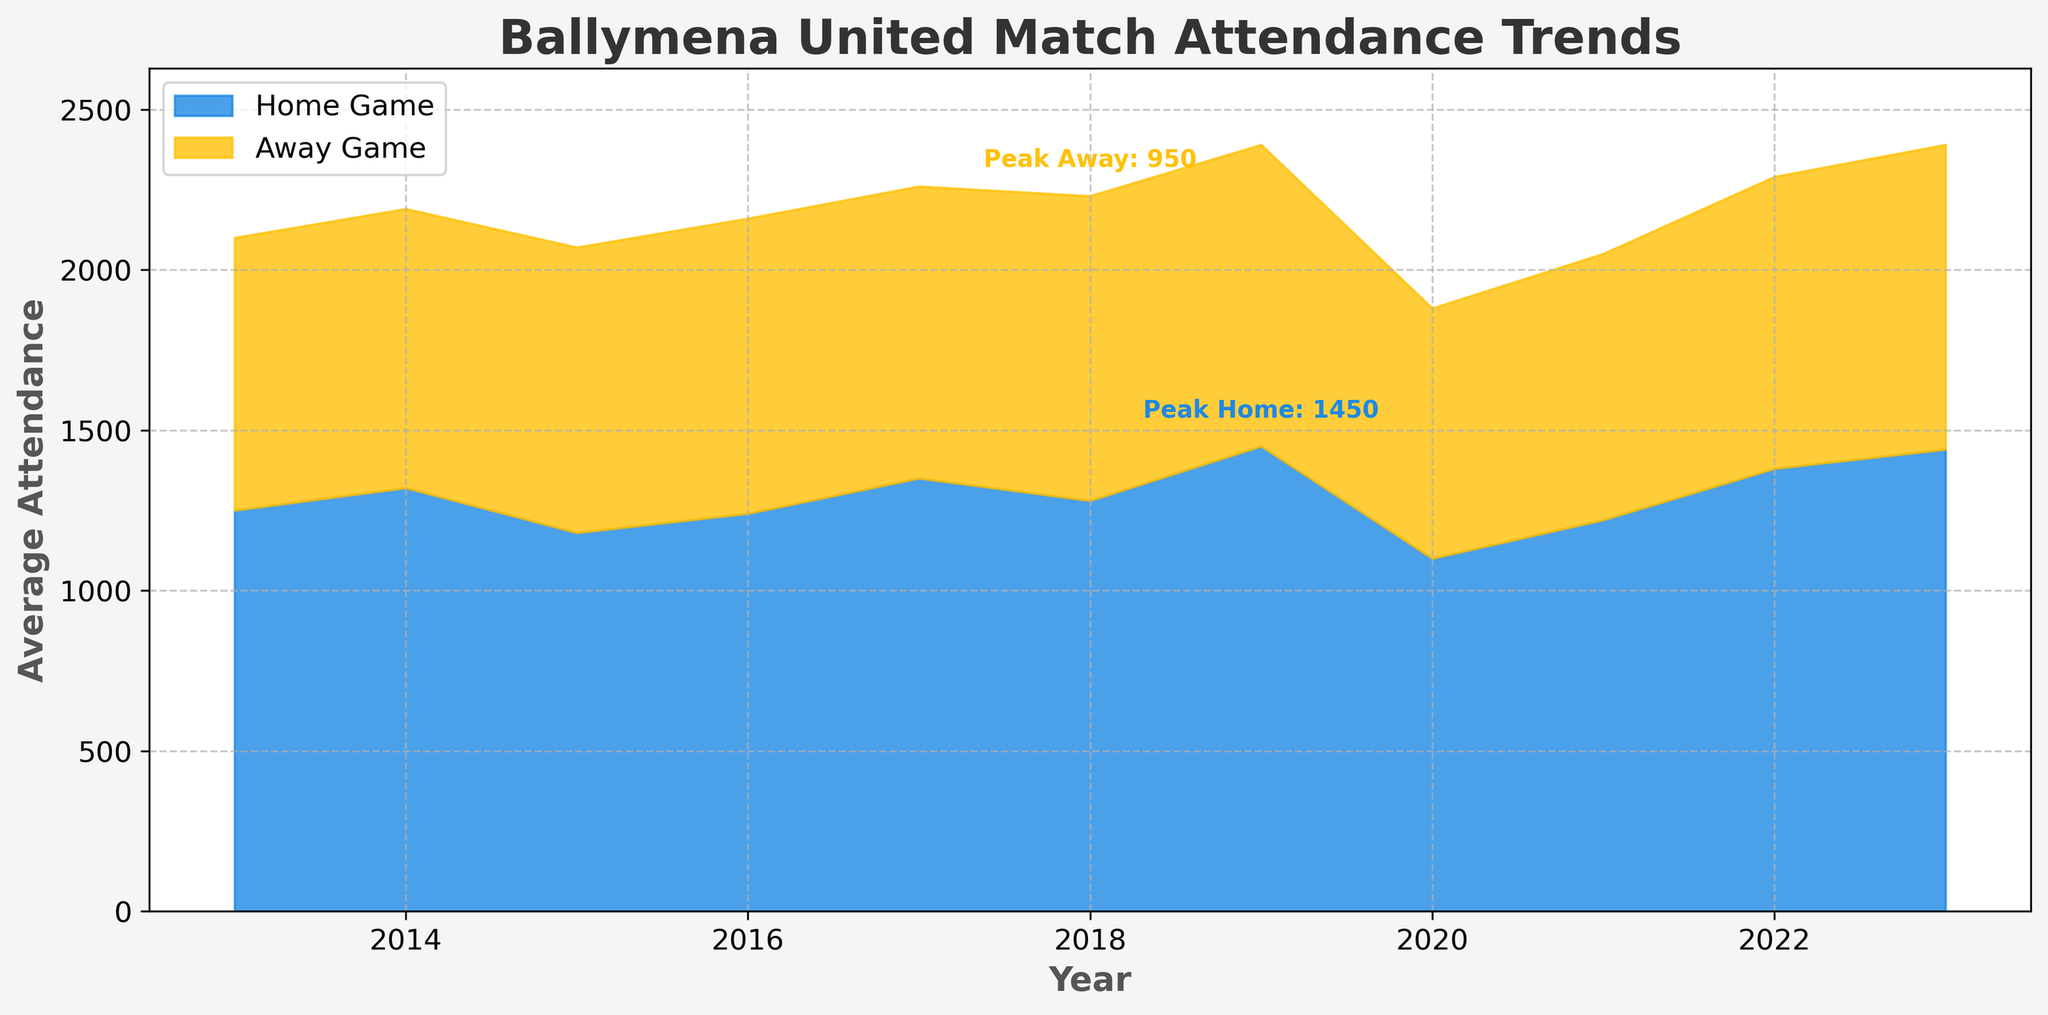What's the title of the figure? The title can be found at the top of the figure and it summarizes the main topic of the graph.
Answer: Ballymena United Match Attendance Trends What is the average home game attendance in 2020? locate the value on the y-axis for the year 2020 in the home game section of the stream graph.
Answer: 1100 Which year saw the peak home game attendance? observe the highest filled area for the home game section on the graph, and locate the corresponding year on the x-axis.
Answer: 2019 What is the difference between home and away game average attendance in 2017? Check the values for both home and away game average attendance in 2017, then subtract the away game attendance from the home game attendance: 1350 - 910.
Answer: 440 During which year was the sum of home and away game average attendance the highest? Add the home and away game average attendance for each year, then find the year with the largest sum.
Answer: 2019 Comparing 2015 and 2018, which year had a higher away game average attendance? Evaluate the away game attendance values for both 2015 and 2018, then identify the year with the higher value.
Answer: 2018 What is the average away game attendance over the entire decade? Sum up all away game average attendance values and divide by the number of years: (850 + 870 + 890 + 920 + 910 + 950 + 940 + 780 + 830 + 910 + 950) / 11.
Answer: 897 How did the home game average attendance trend change from 2020 to 2023? Observe the values for home game attendance from 2020 to 2023 and note the changes: 1100 (2020), 1220 (2021), 1380 (2022), 1440 (2023).
Answer: Increased Which segment has more variability, home games or away games? Compare the range and changes across the values for each segment, assessing the consistency or fluctuation of attendance in each segment.
Answer: Home games What is the difference between the peak home and peak away game attendance? Identify peak values for both home and away game attendance, then subtract the away game peak from the home game peak: 1450 - 950.
Answer: 500 